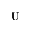<formula> <loc_0><loc_0><loc_500><loc_500>U</formula> 